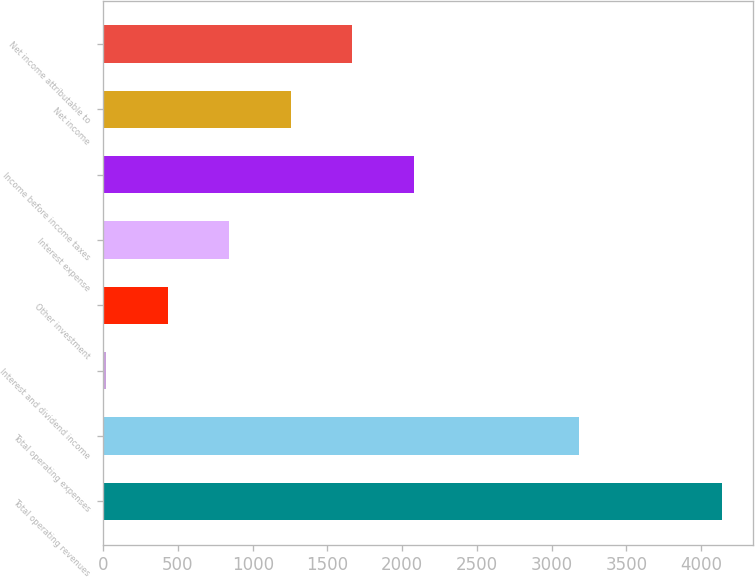Convert chart to OTSL. <chart><loc_0><loc_0><loc_500><loc_500><bar_chart><fcel>Total operating revenues<fcel>Total operating expenses<fcel>Interest and dividend income<fcel>Other investment<fcel>Interest expense<fcel>Income before income taxes<fcel>Net income<fcel>Net income attributable to<nl><fcel>4139.4<fcel>3181.1<fcel>19.3<fcel>431.31<fcel>843.32<fcel>2079.35<fcel>1255.33<fcel>1667.34<nl></chart> 